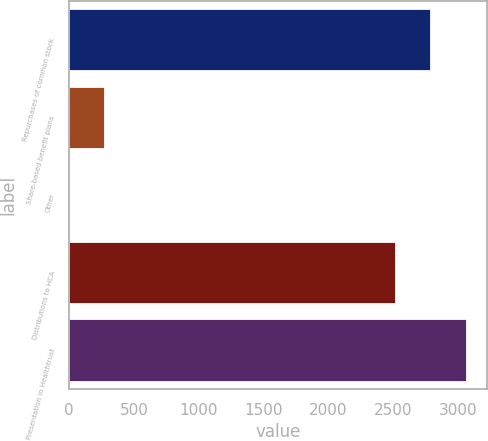Convert chart. <chart><loc_0><loc_0><loc_500><loc_500><bar_chart><fcel>Repurchases of common stock<fcel>Share-based benefit plans<fcel>Other<fcel>Distributions to HCA<fcel>Presentation in Healthtrust<nl><fcel>2794.9<fcel>276.9<fcel>2<fcel>2520<fcel>3069.8<nl></chart> 